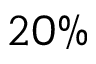Convert formula to latex. <formula><loc_0><loc_0><loc_500><loc_500>2 0 \%</formula> 